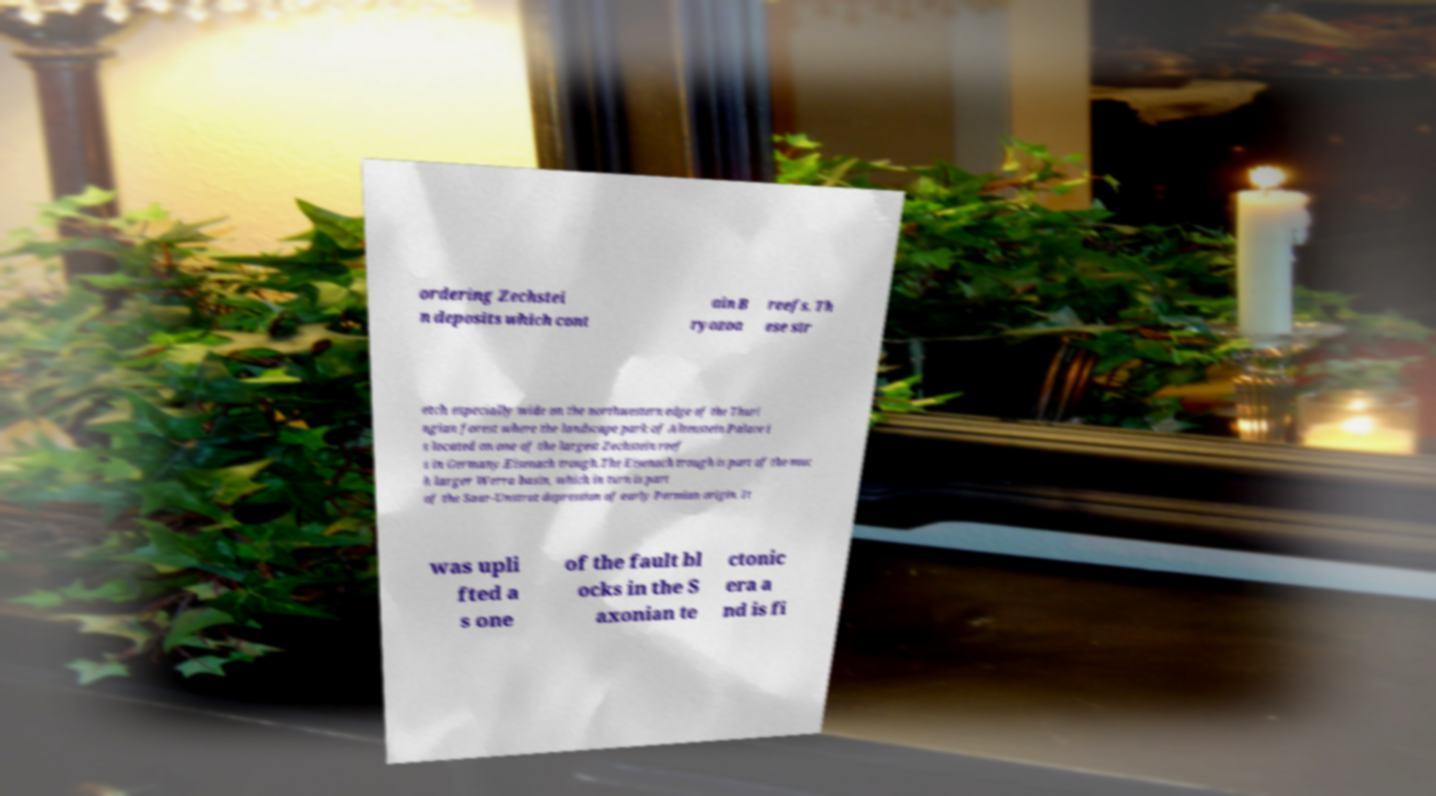What messages or text are displayed in this image? I need them in a readable, typed format. ordering Zechstei n deposits which cont ain B ryozoa reefs. Th ese str etch especially wide on the northwestern edge of the Thuri ngian forest where the landscape park of Altenstein Palace i s located on one of the largest Zechstein reef s in Germany.Eisenach trough.The Eisenach trough is part of the muc h larger Werra basin, which in turn is part of the Saar-Unstrut depression of early Permian origin. It was upli fted a s one of the fault bl ocks in the S axonian te ctonic era a nd is fi 